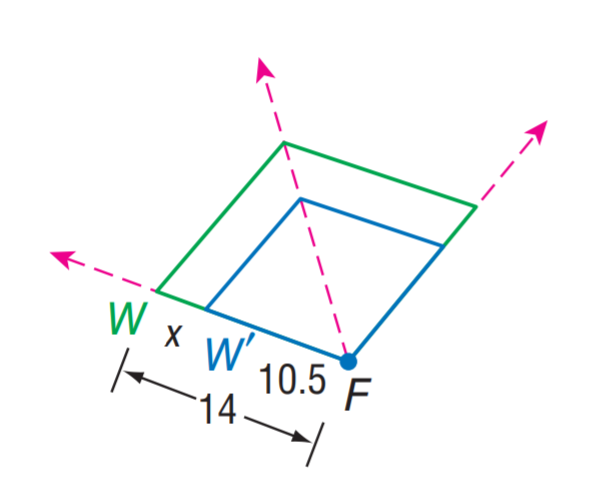Question: Find the scale factor from W to W'.
Choices:
A. 0.75
B. 1.25
C. 1.5
D. 1.75
Answer with the letter. Answer: A 